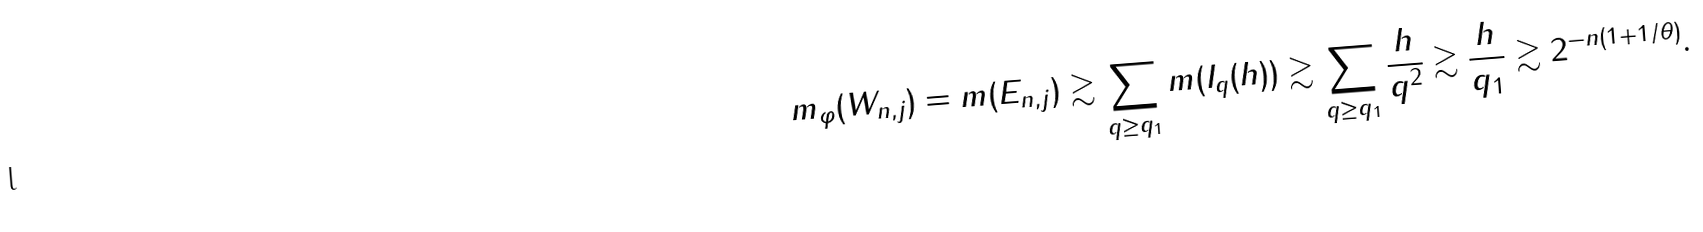Convert formula to latex. <formula><loc_0><loc_0><loc_500><loc_500>m _ { \varphi } ( W _ { n , j } ) = m ( E _ { n , j } ) \gtrsim \sum _ { q \geq q _ { 1 } } m ( I _ { q } ( h ) ) \gtrsim \sum _ { q \geq q _ { 1 } } \frac { h } { q ^ { 2 } } \gtrsim \frac { h } { q _ { 1 } } \gtrsim 2 ^ { - n ( 1 + 1 / \theta ) } .</formula> 